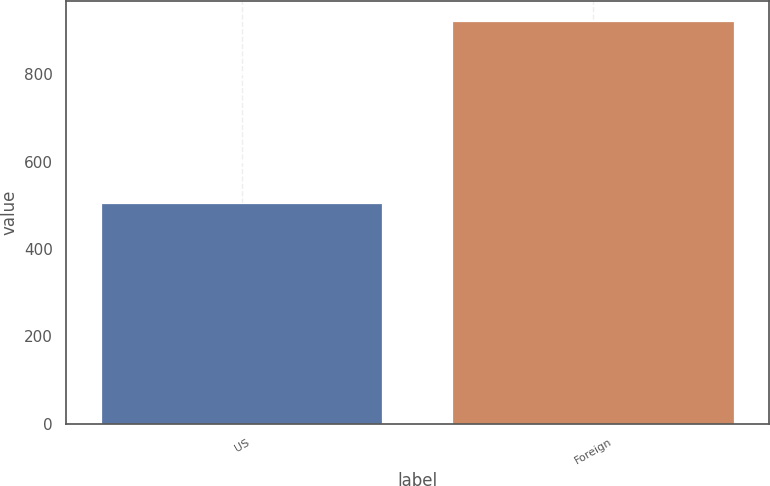Convert chart to OTSL. <chart><loc_0><loc_0><loc_500><loc_500><bar_chart><fcel>US<fcel>Foreign<nl><fcel>506<fcel>921<nl></chart> 